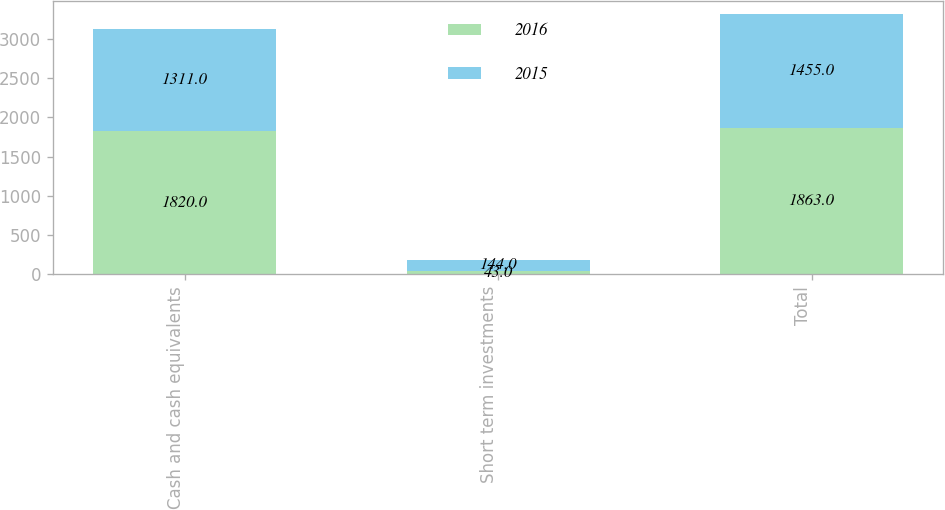Convert chart to OTSL. <chart><loc_0><loc_0><loc_500><loc_500><stacked_bar_chart><ecel><fcel>Cash and cash equivalents<fcel>Short term investments<fcel>Total<nl><fcel>2016<fcel>1820<fcel>43<fcel>1863<nl><fcel>2015<fcel>1311<fcel>144<fcel>1455<nl></chart> 